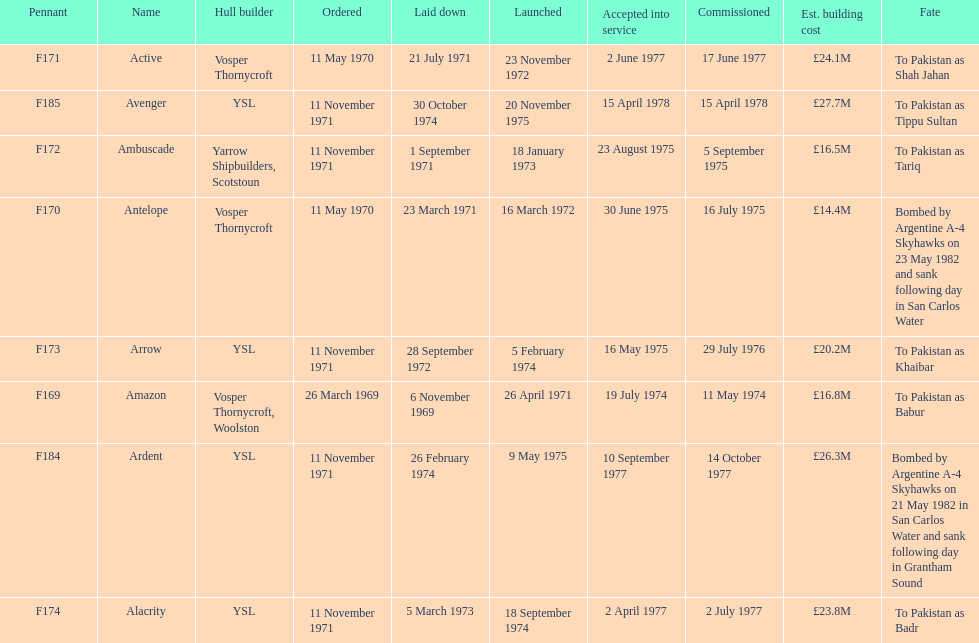How many boats costed less than £20m to build? 3. 